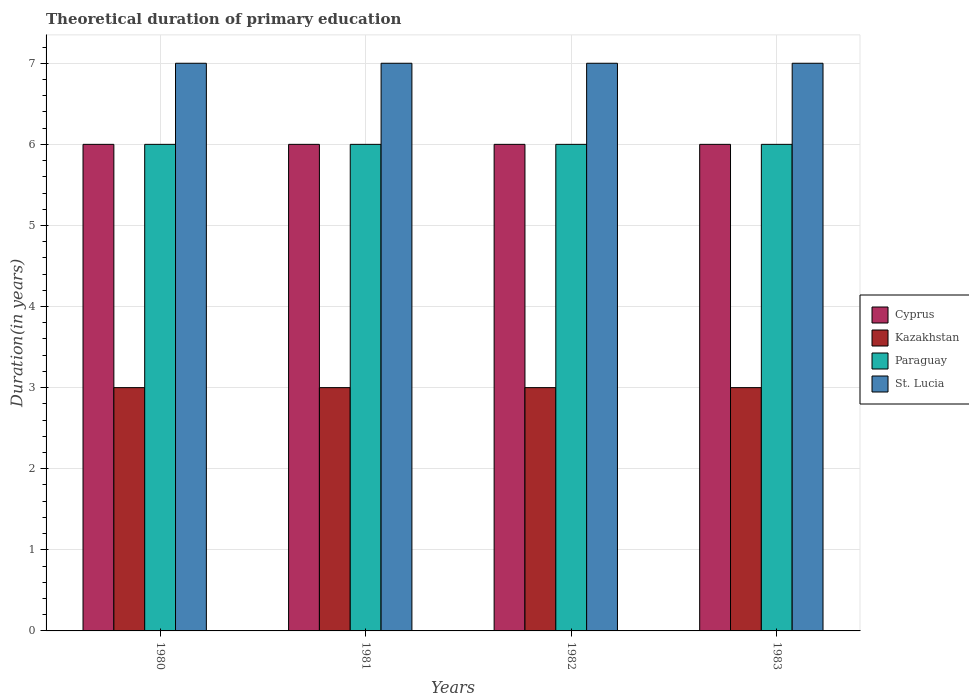How many groups of bars are there?
Keep it short and to the point. 4. Are the number of bars per tick equal to the number of legend labels?
Offer a terse response. Yes. Are the number of bars on each tick of the X-axis equal?
Provide a succinct answer. Yes. How many bars are there on the 4th tick from the left?
Your answer should be very brief. 4. How many bars are there on the 3rd tick from the right?
Keep it short and to the point. 4. What is the total theoretical duration of primary education in Kazakhstan in 1982?
Make the answer very short. 3. In which year was the total theoretical duration of primary education in Paraguay minimum?
Offer a very short reply. 1980. What is the total total theoretical duration of primary education in Kazakhstan in the graph?
Ensure brevity in your answer.  12. What is the difference between the total theoretical duration of primary education in Paraguay in 1981 and the total theoretical duration of primary education in St. Lucia in 1983?
Give a very brief answer. -1. What is the average total theoretical duration of primary education in St. Lucia per year?
Offer a very short reply. 7. In the year 1981, what is the difference between the total theoretical duration of primary education in Cyprus and total theoretical duration of primary education in Paraguay?
Ensure brevity in your answer.  0. What does the 2nd bar from the left in 1982 represents?
Offer a terse response. Kazakhstan. What does the 1st bar from the right in 1983 represents?
Give a very brief answer. St. Lucia. How many bars are there?
Keep it short and to the point. 16. How many years are there in the graph?
Offer a very short reply. 4. Are the values on the major ticks of Y-axis written in scientific E-notation?
Your answer should be very brief. No. Does the graph contain any zero values?
Make the answer very short. No. How are the legend labels stacked?
Your answer should be very brief. Vertical. What is the title of the graph?
Your answer should be compact. Theoretical duration of primary education. What is the label or title of the Y-axis?
Make the answer very short. Duration(in years). What is the Duration(in years) in Cyprus in 1980?
Offer a terse response. 6. What is the Duration(in years) in Kazakhstan in 1980?
Offer a terse response. 3. What is the Duration(in years) in St. Lucia in 1980?
Offer a terse response. 7. What is the Duration(in years) of Paraguay in 1981?
Provide a short and direct response. 6. What is the Duration(in years) in St. Lucia in 1981?
Make the answer very short. 7. What is the Duration(in years) in Paraguay in 1982?
Make the answer very short. 6. What is the Duration(in years) of Cyprus in 1983?
Ensure brevity in your answer.  6. What is the Duration(in years) of Paraguay in 1983?
Offer a terse response. 6. Across all years, what is the maximum Duration(in years) in Kazakhstan?
Make the answer very short. 3. Across all years, what is the maximum Duration(in years) in Paraguay?
Provide a short and direct response. 6. Across all years, what is the minimum Duration(in years) of Paraguay?
Keep it short and to the point. 6. Across all years, what is the minimum Duration(in years) in St. Lucia?
Your answer should be very brief. 7. What is the total Duration(in years) of Cyprus in the graph?
Your response must be concise. 24. What is the total Duration(in years) of Kazakhstan in the graph?
Ensure brevity in your answer.  12. What is the total Duration(in years) in St. Lucia in the graph?
Make the answer very short. 28. What is the difference between the Duration(in years) of Cyprus in 1980 and that in 1981?
Your response must be concise. 0. What is the difference between the Duration(in years) in Kazakhstan in 1980 and that in 1981?
Give a very brief answer. 0. What is the difference between the Duration(in years) of Kazakhstan in 1980 and that in 1982?
Provide a short and direct response. 0. What is the difference between the Duration(in years) in Paraguay in 1980 and that in 1982?
Ensure brevity in your answer.  0. What is the difference between the Duration(in years) of St. Lucia in 1980 and that in 1982?
Keep it short and to the point. 0. What is the difference between the Duration(in years) in St. Lucia in 1980 and that in 1983?
Offer a very short reply. 0. What is the difference between the Duration(in years) in St. Lucia in 1981 and that in 1982?
Your response must be concise. 0. What is the difference between the Duration(in years) in Cyprus in 1981 and that in 1983?
Give a very brief answer. 0. What is the difference between the Duration(in years) of Paraguay in 1981 and that in 1983?
Offer a terse response. 0. What is the difference between the Duration(in years) in Kazakhstan in 1982 and that in 1983?
Your response must be concise. 0. What is the difference between the Duration(in years) of Paraguay in 1982 and that in 1983?
Keep it short and to the point. 0. What is the difference between the Duration(in years) in Cyprus in 1980 and the Duration(in years) in Kazakhstan in 1981?
Ensure brevity in your answer.  3. What is the difference between the Duration(in years) of Cyprus in 1980 and the Duration(in years) of St. Lucia in 1981?
Offer a very short reply. -1. What is the difference between the Duration(in years) in Cyprus in 1980 and the Duration(in years) in Kazakhstan in 1982?
Offer a terse response. 3. What is the difference between the Duration(in years) in Cyprus in 1980 and the Duration(in years) in Paraguay in 1982?
Your answer should be compact. 0. What is the difference between the Duration(in years) in Kazakhstan in 1980 and the Duration(in years) in Paraguay in 1982?
Keep it short and to the point. -3. What is the difference between the Duration(in years) in Kazakhstan in 1980 and the Duration(in years) in Paraguay in 1983?
Provide a succinct answer. -3. What is the difference between the Duration(in years) of Kazakhstan in 1980 and the Duration(in years) of St. Lucia in 1983?
Provide a short and direct response. -4. What is the difference between the Duration(in years) in Paraguay in 1980 and the Duration(in years) in St. Lucia in 1983?
Your response must be concise. -1. What is the difference between the Duration(in years) in Cyprus in 1981 and the Duration(in years) in Kazakhstan in 1982?
Your answer should be compact. 3. What is the difference between the Duration(in years) of Cyprus in 1981 and the Duration(in years) of St. Lucia in 1982?
Keep it short and to the point. -1. What is the difference between the Duration(in years) of Cyprus in 1981 and the Duration(in years) of Kazakhstan in 1983?
Make the answer very short. 3. What is the difference between the Duration(in years) in Cyprus in 1981 and the Duration(in years) in St. Lucia in 1983?
Provide a short and direct response. -1. What is the difference between the Duration(in years) in Cyprus in 1982 and the Duration(in years) in Paraguay in 1983?
Offer a terse response. 0. What is the difference between the Duration(in years) of Kazakhstan in 1982 and the Duration(in years) of Paraguay in 1983?
Provide a succinct answer. -3. What is the difference between the Duration(in years) of Kazakhstan in 1982 and the Duration(in years) of St. Lucia in 1983?
Your answer should be compact. -4. In the year 1980, what is the difference between the Duration(in years) of Kazakhstan and Duration(in years) of Paraguay?
Offer a terse response. -3. In the year 1980, what is the difference between the Duration(in years) of Paraguay and Duration(in years) of St. Lucia?
Your response must be concise. -1. In the year 1981, what is the difference between the Duration(in years) in Cyprus and Duration(in years) in Kazakhstan?
Provide a succinct answer. 3. In the year 1981, what is the difference between the Duration(in years) of Cyprus and Duration(in years) of Paraguay?
Provide a succinct answer. 0. In the year 1981, what is the difference between the Duration(in years) in Kazakhstan and Duration(in years) in Paraguay?
Offer a terse response. -3. In the year 1981, what is the difference between the Duration(in years) in Kazakhstan and Duration(in years) in St. Lucia?
Give a very brief answer. -4. In the year 1982, what is the difference between the Duration(in years) in Cyprus and Duration(in years) in Paraguay?
Your answer should be very brief. 0. In the year 1982, what is the difference between the Duration(in years) of Kazakhstan and Duration(in years) of Paraguay?
Keep it short and to the point. -3. In the year 1982, what is the difference between the Duration(in years) of Kazakhstan and Duration(in years) of St. Lucia?
Give a very brief answer. -4. In the year 1982, what is the difference between the Duration(in years) in Paraguay and Duration(in years) in St. Lucia?
Your response must be concise. -1. In the year 1983, what is the difference between the Duration(in years) of Kazakhstan and Duration(in years) of Paraguay?
Provide a short and direct response. -3. In the year 1983, what is the difference between the Duration(in years) in Paraguay and Duration(in years) in St. Lucia?
Your answer should be compact. -1. What is the ratio of the Duration(in years) of Cyprus in 1980 to that in 1981?
Ensure brevity in your answer.  1. What is the ratio of the Duration(in years) in Paraguay in 1980 to that in 1981?
Your response must be concise. 1. What is the ratio of the Duration(in years) in St. Lucia in 1980 to that in 1981?
Offer a terse response. 1. What is the ratio of the Duration(in years) in Kazakhstan in 1980 to that in 1982?
Ensure brevity in your answer.  1. What is the ratio of the Duration(in years) in Paraguay in 1980 to that in 1982?
Keep it short and to the point. 1. What is the ratio of the Duration(in years) in St. Lucia in 1981 to that in 1982?
Offer a very short reply. 1. What is the ratio of the Duration(in years) of Cyprus in 1981 to that in 1983?
Keep it short and to the point. 1. What is the ratio of the Duration(in years) of Kazakhstan in 1981 to that in 1983?
Provide a short and direct response. 1. What is the ratio of the Duration(in years) of St. Lucia in 1981 to that in 1983?
Offer a terse response. 1. What is the ratio of the Duration(in years) of Kazakhstan in 1982 to that in 1983?
Ensure brevity in your answer.  1. What is the difference between the highest and the second highest Duration(in years) of Cyprus?
Your response must be concise. 0. What is the difference between the highest and the second highest Duration(in years) of Kazakhstan?
Your answer should be compact. 0. What is the difference between the highest and the second highest Duration(in years) of St. Lucia?
Your answer should be compact. 0. What is the difference between the highest and the lowest Duration(in years) of Kazakhstan?
Your answer should be very brief. 0. What is the difference between the highest and the lowest Duration(in years) of St. Lucia?
Ensure brevity in your answer.  0. 